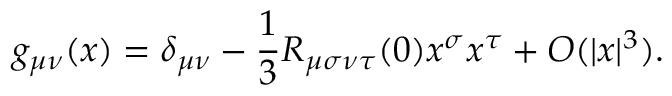Convert formula to latex. <formula><loc_0><loc_0><loc_500><loc_500>g _ { \mu \nu } ( x ) = \delta _ { \mu \nu } - { \frac { 1 } { 3 } } R _ { \mu \sigma \nu \tau } ( 0 ) x ^ { \sigma } x ^ { \tau } + O ( | x | ^ { 3 } ) .</formula> 